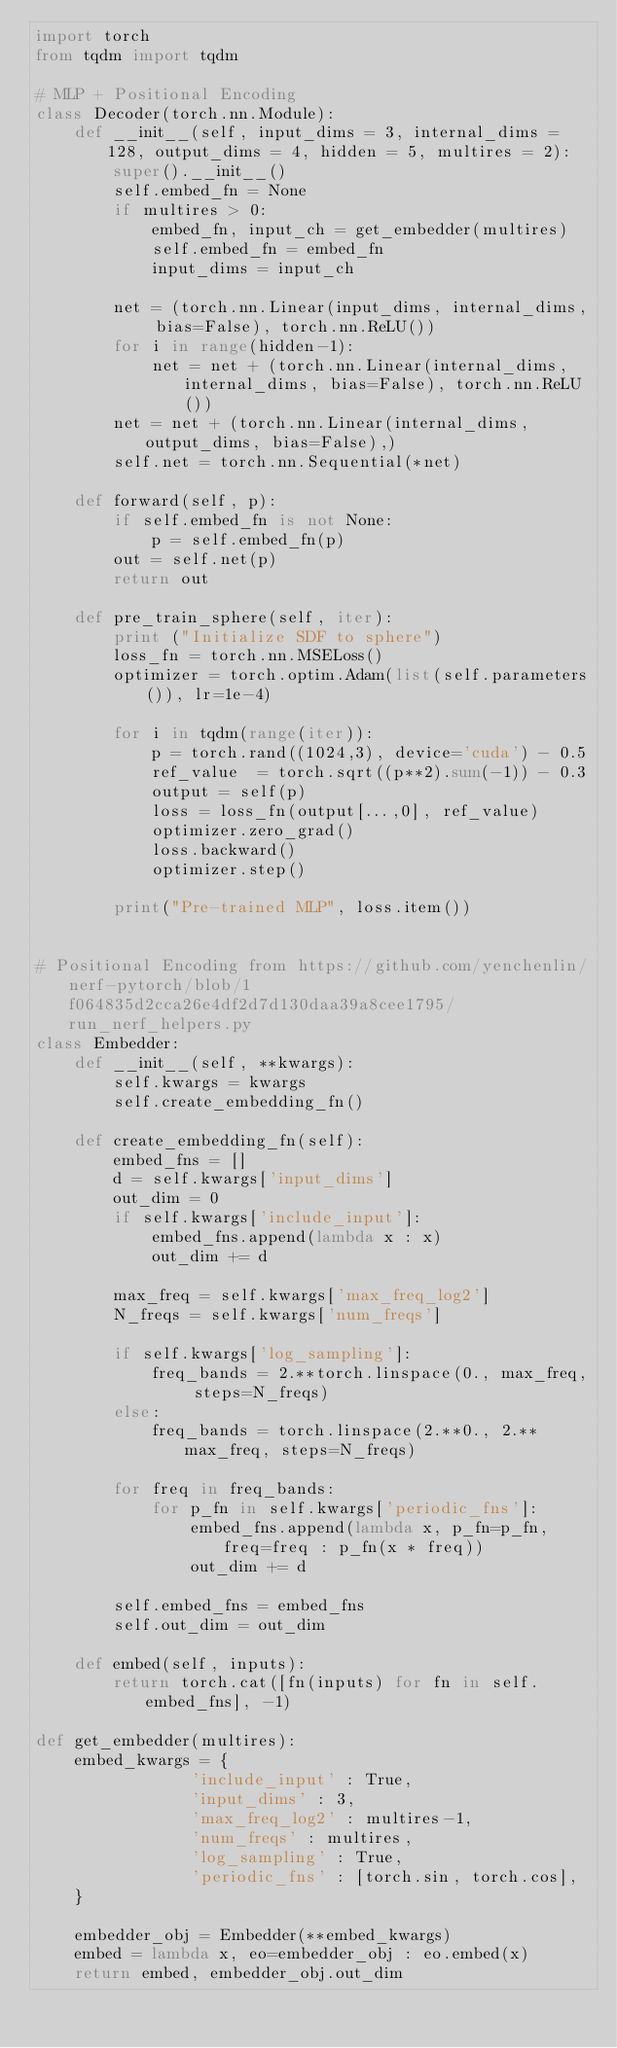Convert code to text. <code><loc_0><loc_0><loc_500><loc_500><_Python_>import torch
from tqdm import tqdm

# MLP + Positional Encoding
class Decoder(torch.nn.Module):
    def __init__(self, input_dims = 3, internal_dims = 128, output_dims = 4, hidden = 5, multires = 2):
        super().__init__()
        self.embed_fn = None
        if multires > 0:
            embed_fn, input_ch = get_embedder(multires)
            self.embed_fn = embed_fn
            input_dims = input_ch

        net = (torch.nn.Linear(input_dims, internal_dims, bias=False), torch.nn.ReLU())
        for i in range(hidden-1):
            net = net + (torch.nn.Linear(internal_dims, internal_dims, bias=False), torch.nn.ReLU())
        net = net + (torch.nn.Linear(internal_dims, output_dims, bias=False),)
        self.net = torch.nn.Sequential(*net)

    def forward(self, p):
        if self.embed_fn is not None:
            p = self.embed_fn(p)
        out = self.net(p)
        return out

    def pre_train_sphere(self, iter):
        print ("Initialize SDF to sphere")
        loss_fn = torch.nn.MSELoss()
        optimizer = torch.optim.Adam(list(self.parameters()), lr=1e-4)

        for i in tqdm(range(iter)):
            p = torch.rand((1024,3), device='cuda') - 0.5
            ref_value  = torch.sqrt((p**2).sum(-1)) - 0.3
            output = self(p)
            loss = loss_fn(output[...,0], ref_value)
            optimizer.zero_grad()
            loss.backward()
            optimizer.step()

        print("Pre-trained MLP", loss.item())


# Positional Encoding from https://github.com/yenchenlin/nerf-pytorch/blob/1f064835d2cca26e4df2d7d130daa39a8cee1795/run_nerf_helpers.py
class Embedder:
    def __init__(self, **kwargs):
        self.kwargs = kwargs
        self.create_embedding_fn()
        
    def create_embedding_fn(self):
        embed_fns = []
        d = self.kwargs['input_dims']
        out_dim = 0
        if self.kwargs['include_input']:
            embed_fns.append(lambda x : x)
            out_dim += d
            
        max_freq = self.kwargs['max_freq_log2']
        N_freqs = self.kwargs['num_freqs']
        
        if self.kwargs['log_sampling']:
            freq_bands = 2.**torch.linspace(0., max_freq, steps=N_freqs)
        else:
            freq_bands = torch.linspace(2.**0., 2.**max_freq, steps=N_freqs)
            
        for freq in freq_bands:
            for p_fn in self.kwargs['periodic_fns']:
                embed_fns.append(lambda x, p_fn=p_fn, freq=freq : p_fn(x * freq))
                out_dim += d
                    
        self.embed_fns = embed_fns
        self.out_dim = out_dim
        
    def embed(self, inputs):
        return torch.cat([fn(inputs) for fn in self.embed_fns], -1)

def get_embedder(multires):
    embed_kwargs = {
                'include_input' : True,
                'input_dims' : 3,
                'max_freq_log2' : multires-1,
                'num_freqs' : multires,
                'log_sampling' : True,
                'periodic_fns' : [torch.sin, torch.cos],
    }
    
    embedder_obj = Embedder(**embed_kwargs)
    embed = lambda x, eo=embedder_obj : eo.embed(x)
    return embed, embedder_obj.out_dim
</code> 